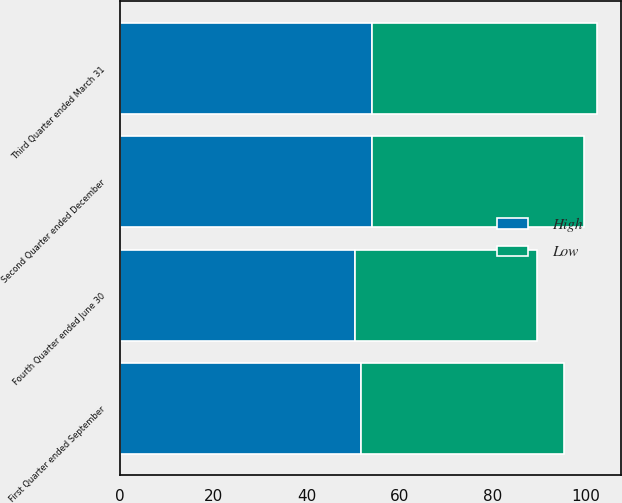<chart> <loc_0><loc_0><loc_500><loc_500><stacked_bar_chart><ecel><fcel>First Quarter ended September<fcel>Second Quarter ended December<fcel>Third Quarter ended March 31<fcel>Fourth Quarter ended June 30<nl><fcel>High<fcel>51.7<fcel>54.09<fcel>54.18<fcel>50.39<nl><fcel>Low<fcel>43.6<fcel>45.52<fcel>48.2<fcel>39.07<nl></chart> 